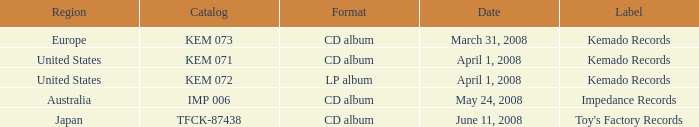Which Format has a Date of may 24, 2008? CD album. Could you parse the entire table as a dict? {'header': ['Region', 'Catalog', 'Format', 'Date', 'Label'], 'rows': [['Europe', 'KEM 073', 'CD album', 'March 31, 2008', 'Kemado Records'], ['United States', 'KEM 071', 'CD album', 'April 1, 2008', 'Kemado Records'], ['United States', 'KEM 072', 'LP album', 'April 1, 2008', 'Kemado Records'], ['Australia', 'IMP 006', 'CD album', 'May 24, 2008', 'Impedance Records'], ['Japan', 'TFCK-87438', 'CD album', 'June 11, 2008', "Toy's Factory Records"]]} 